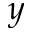Convert formula to latex. <formula><loc_0><loc_0><loc_500><loc_500>y</formula> 